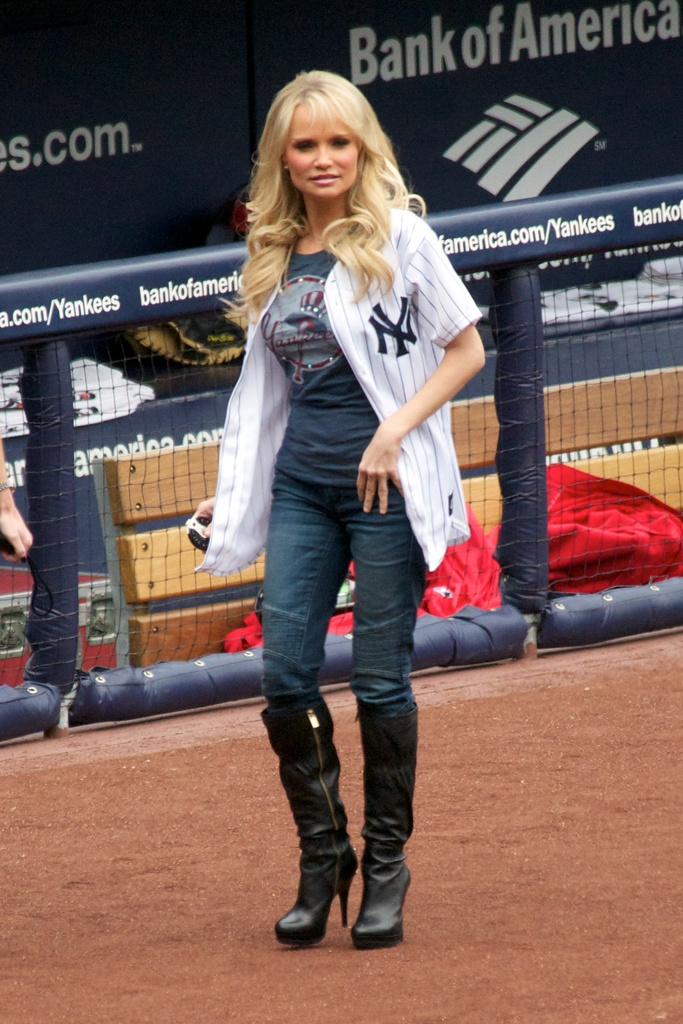Provide a one-sentence caption for the provided image. A woman in a Yankees jersey and knee-high boots stands in front of a dugout with Bank of America signage, highlighting the company's sponsorship at a Yankees game. 